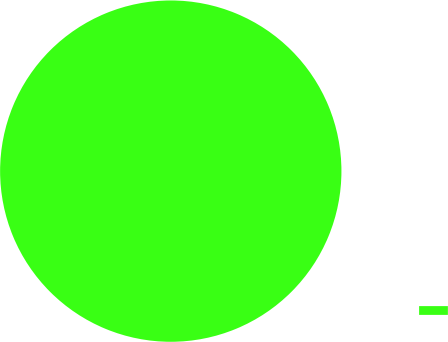Convert chart. <chart><loc_0><loc_0><loc_500><loc_500><pie_chart><ecel><nl><fcel>100.0%<nl></chart> 